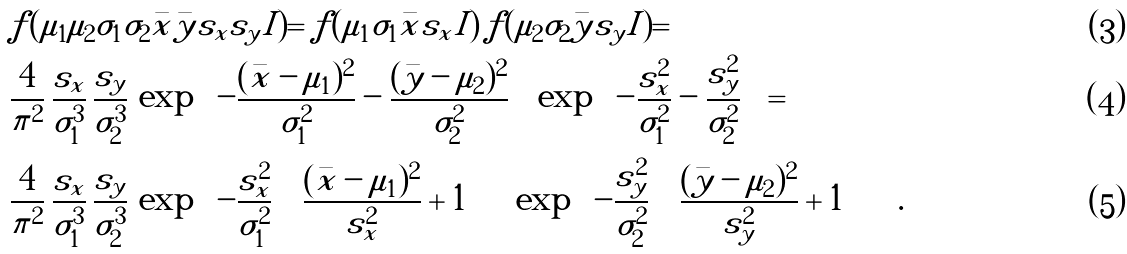<formula> <loc_0><loc_0><loc_500><loc_500>& f ( \mu _ { 1 } \mu _ { 2 } \sigma _ { 1 } \sigma _ { 2 } | \bar { x } \bar { y } s _ { x } s _ { y } I ) = f ( \mu _ { 1 } \sigma _ { 1 } | \bar { x } s _ { x } I ) \, f ( \mu _ { 2 } \sigma _ { 2 } | \bar { y } s _ { y } I ) = \\ & \frac { 4 } { \pi ^ { 2 } } \, \frac { s _ { x } } { \sigma _ { 1 } ^ { 3 } } \, \frac { s _ { y } } { \sigma _ { 2 } ^ { 3 } } \, \exp \left \{ - \frac { ( \bar { x } - \mu _ { 1 } ) ^ { 2 } } { \sigma _ { 1 } ^ { 2 } } - \frac { ( \bar { y } - \mu _ { 2 } ) ^ { 2 } } { \sigma _ { 2 } ^ { 2 } } \right \} \, \exp \left \{ - \frac { s _ { x } ^ { 2 } } { \sigma _ { 1 } ^ { 2 } } - \frac { s _ { y } ^ { 2 } } { \sigma _ { 2 } ^ { 2 } } \right \} = \\ & \frac { 4 } { \pi ^ { 2 } } \, \frac { s _ { x } } { \sigma _ { 1 } ^ { 3 } } \, \frac { s _ { y } } { \sigma _ { 2 } ^ { 3 } } \, \exp \left \{ - \frac { s _ { x } ^ { 2 } } { \sigma _ { 1 } ^ { 2 } } \, \left [ \frac { ( \bar { x } - \mu _ { 1 } ) ^ { 2 } } { s _ { x } ^ { 2 } } + 1 \right ] \right \} \, \exp \left \{ - \frac { s _ { y } ^ { 2 } } { \sigma _ { 2 } ^ { 2 } } \, \left [ \frac { ( \bar { y } - \mu _ { 2 } ) ^ { 2 } } { s _ { y } ^ { 2 } } + 1 \right ] \right \} \ .</formula> 